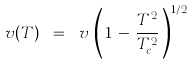Convert formula to latex. <formula><loc_0><loc_0><loc_500><loc_500>v ( T ) \ = \ v \, \left ( \, 1 \, - \, \frac { T ^ { 2 } } { T _ { c } ^ { 2 } } \, \right ) ^ { 1 / 2 }</formula> 